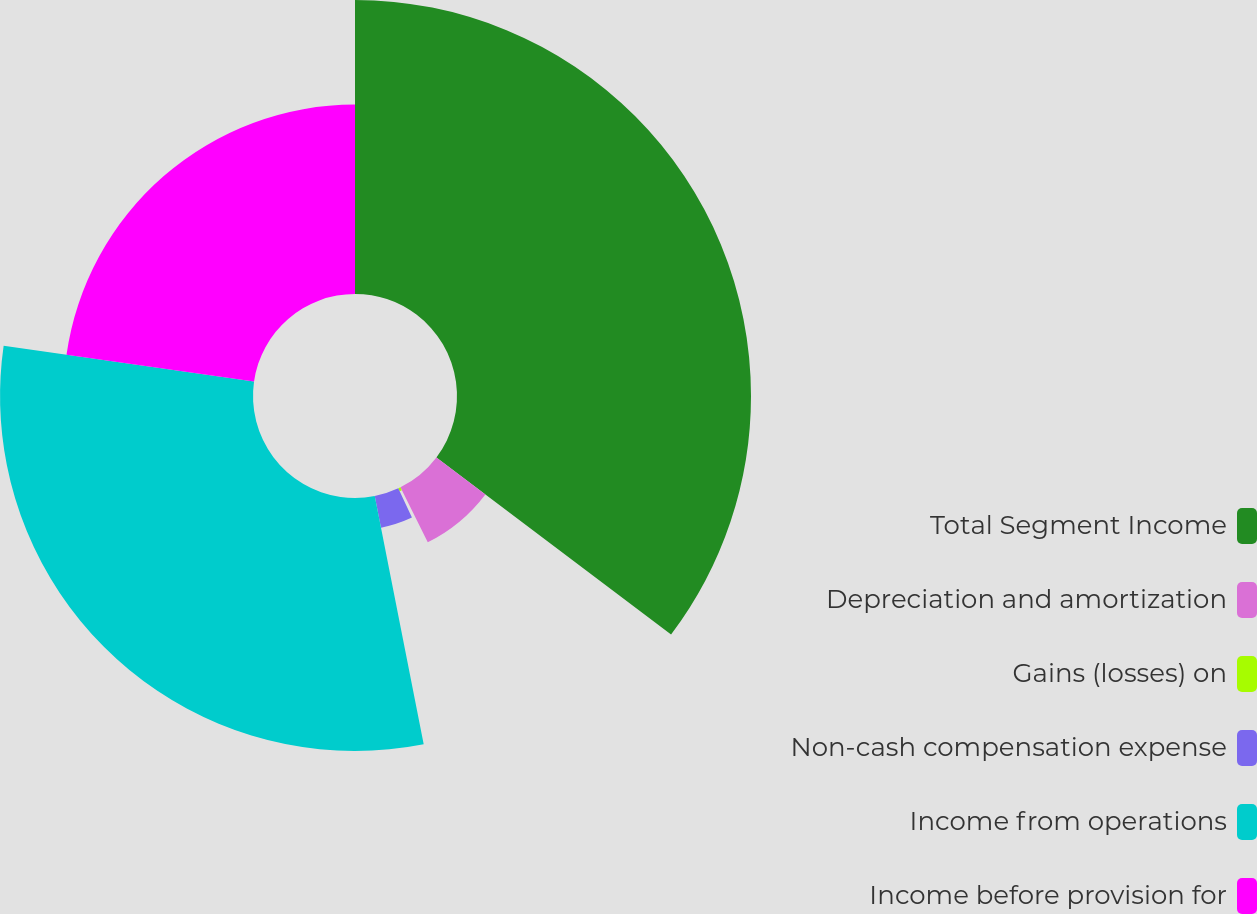<chart> <loc_0><loc_0><loc_500><loc_500><pie_chart><fcel>Total Segment Income<fcel>Depreciation and amortization<fcel>Gains (losses) on<fcel>Non-cash compensation expense<fcel>Income from operations<fcel>Income before provision for<nl><fcel>35.29%<fcel>7.36%<fcel>0.38%<fcel>3.87%<fcel>30.36%<fcel>22.74%<nl></chart> 